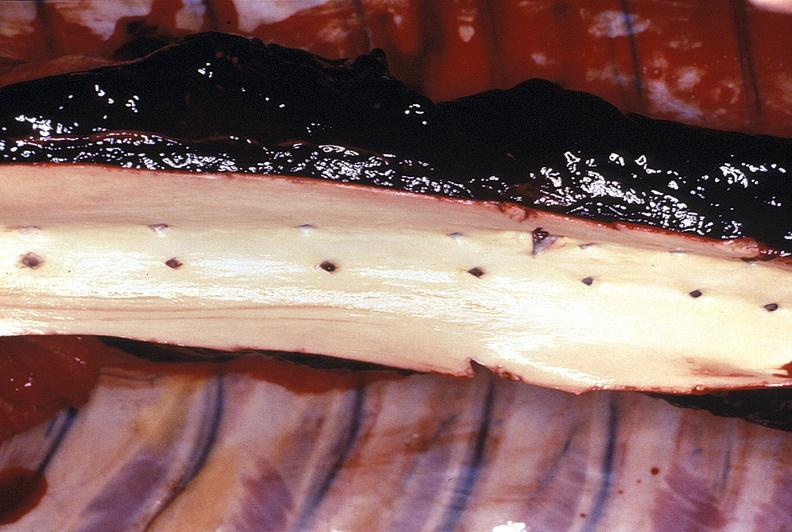does this image show aorta, normal intima?
Answer the question using a single word or phrase. Yes 